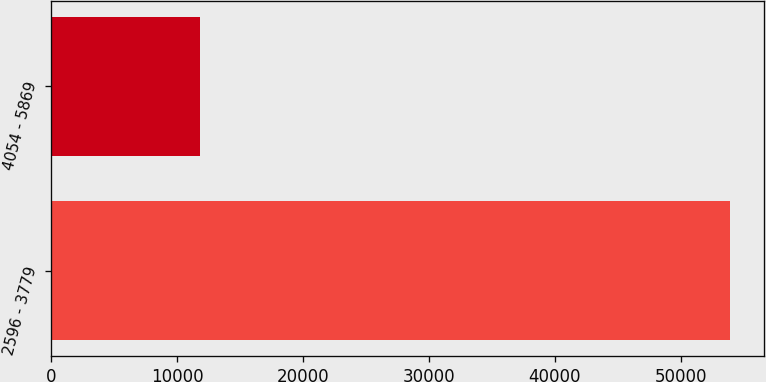Convert chart. <chart><loc_0><loc_0><loc_500><loc_500><bar_chart><fcel>2596 - 3779<fcel>4054 - 5869<nl><fcel>53922<fcel>11810<nl></chart> 